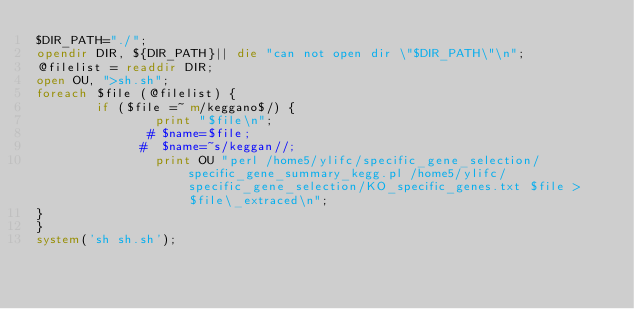<code> <loc_0><loc_0><loc_500><loc_500><_Perl_>$DIR_PATH="./";
opendir DIR, ${DIR_PATH}|| die "can not open dir \"$DIR_PATH\"\n";
@filelist = readdir DIR;
open OU, ">sh.sh";
foreach $file (@filelist) {
        if ($file =~ m/keggano$/) {
                print "$file\n";
               # $name=$file;
              #  $name=~s/keggan//;
                print OU "perl /home5/ylifc/specific_gene_selection/specific_gene_summary_kegg.pl /home5/ylifc/specific_gene_selection/KO_specific_genes.txt $file > $file\_extraced\n";
}
}
system('sh sh.sh');


</code> 